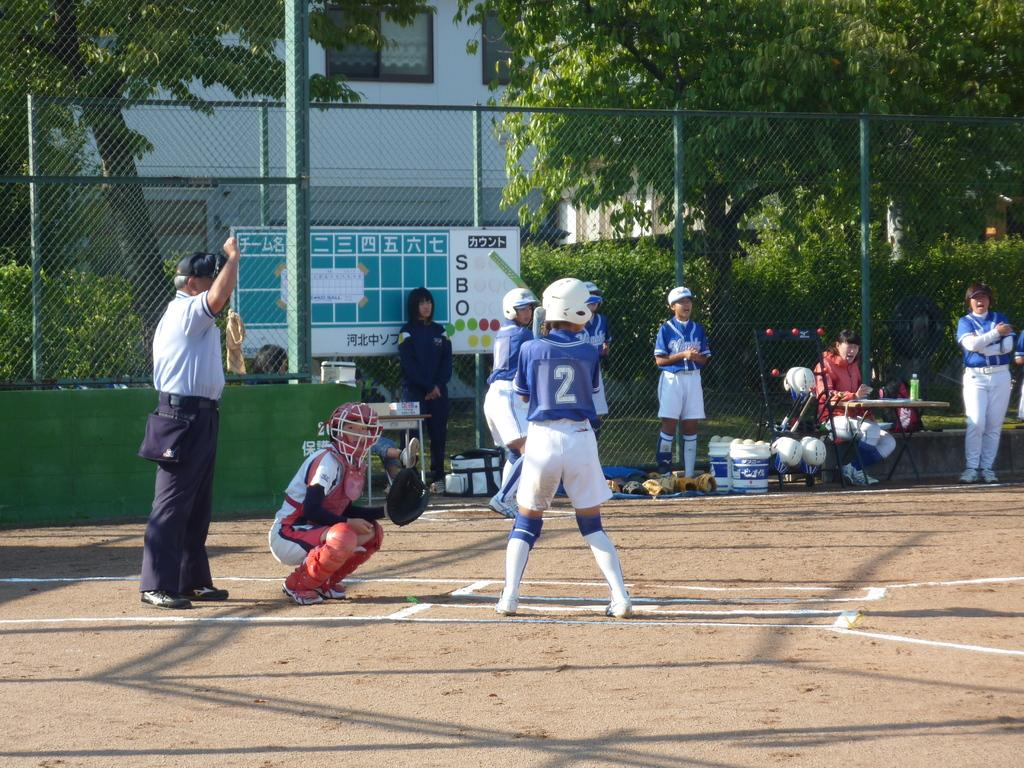<image>
Present a compact description of the photo's key features. a batter getting ready to hit a ball with the number 12 on their jersey 